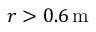<formula> <loc_0><loc_0><loc_500><loc_500>r > 0 . 6 { \, m }</formula> 